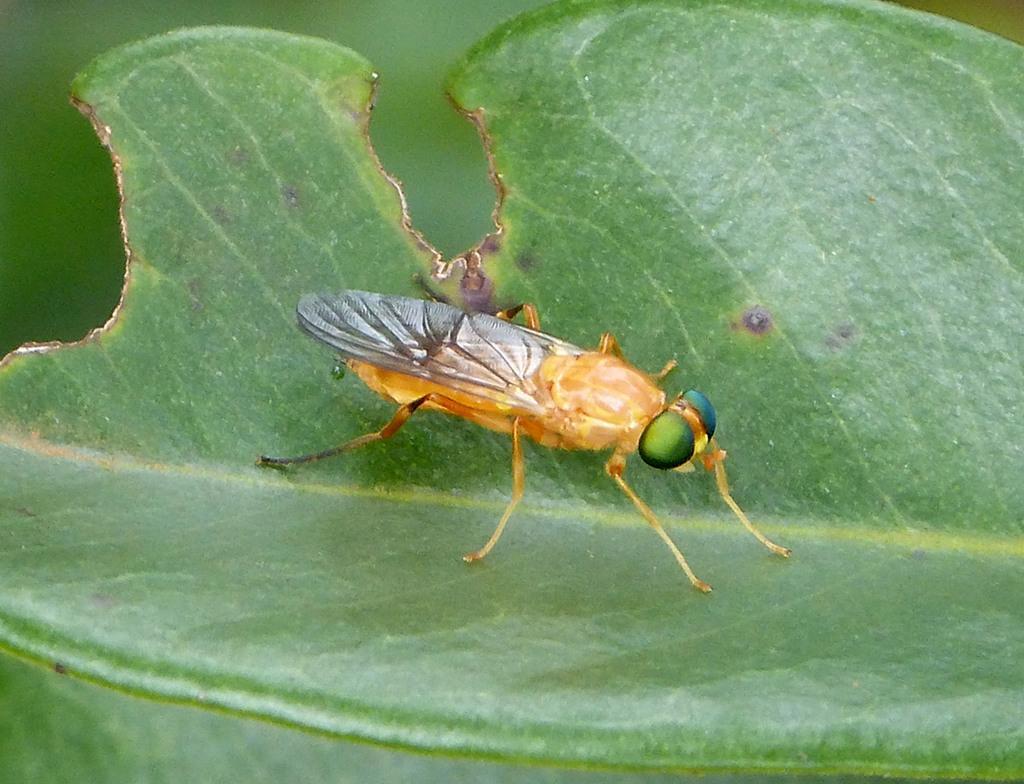Please provide a concise description of this image. In this picture there is a brown color insect sitting on the green leaf. Behind there is a blur background. 